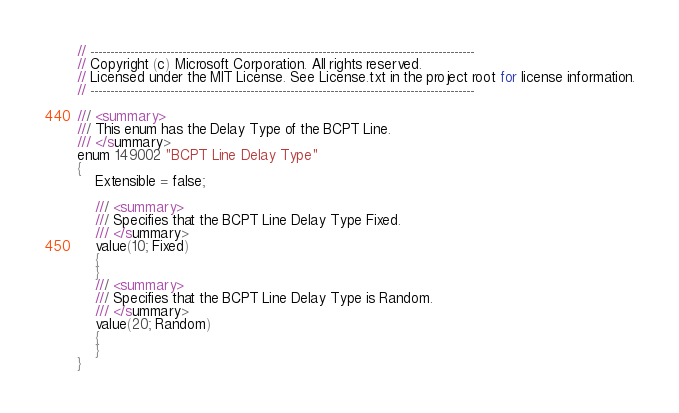<code> <loc_0><loc_0><loc_500><loc_500><_Perl_>// ------------------------------------------------------------------------------------------------
// Copyright (c) Microsoft Corporation. All rights reserved.
// Licensed under the MIT License. See License.txt in the project root for license information.
// ------------------------------------------------------------------------------------------------

/// <summary>
/// This enum has the Delay Type of the BCPT Line.
/// </summary>
enum 149002 "BCPT Line Delay Type"
{
    Extensible = false;

    /// <summary>
    /// Specifies that the BCPT Line Delay Type Fixed.
    /// </summary>
    value(10; Fixed)
    {
    }
    /// <summary>
    /// Specifies that the BCPT Line Delay Type is Random.
    /// </summary>
    value(20; Random)
    {
    }
}</code> 